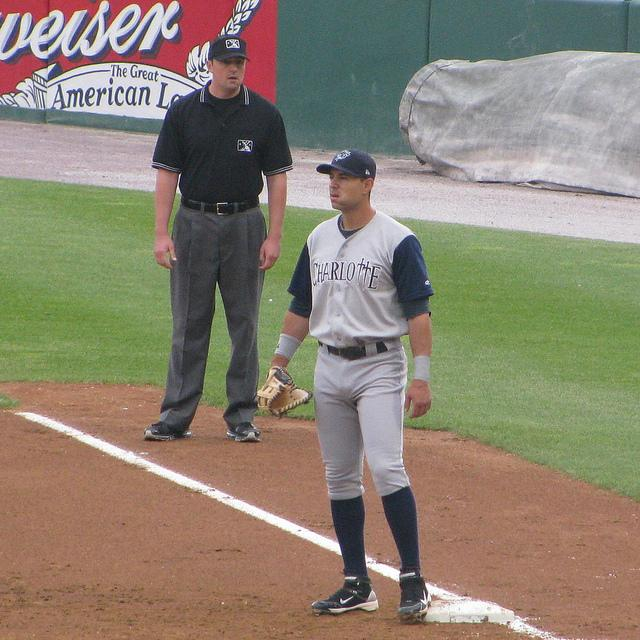What is the person dress in black's job? Please explain your reasoning. referee. They are not in the player uniform, and their job is to watch and make sure the players are correctly following the rules. 